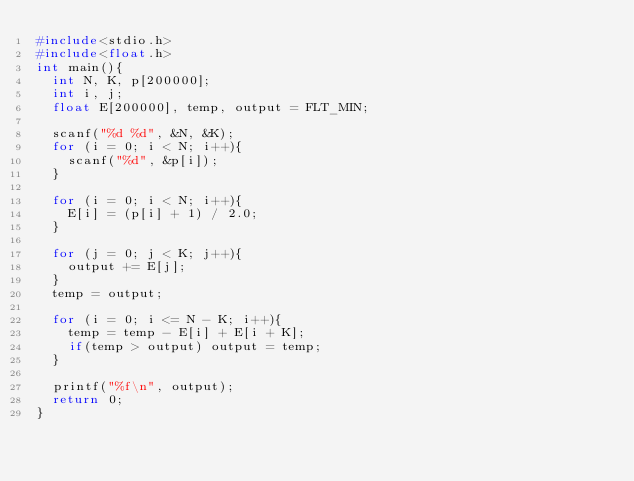<code> <loc_0><loc_0><loc_500><loc_500><_C_>#include<stdio.h>
#include<float.h>
int main(){
	int N, K, p[200000];
	int i, j;
	float E[200000], temp, output = FLT_MIN;

	scanf("%d %d", &N, &K);
	for (i = 0; i < N; i++){
		scanf("%d", &p[i]);
	}

	for (i = 0; i < N; i++){
		E[i] = (p[i] + 1) / 2.0;
	}

	for (j = 0; j < K; j++){
		output += E[j];
	}
	temp = output;

	for (i = 0; i <= N - K; i++){
		temp = temp - E[i] + E[i + K];
		if(temp > output) output = temp;
	}

	printf("%f\n", output);
	return 0;
}</code> 